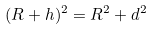<formula> <loc_0><loc_0><loc_500><loc_500>( R + h ) ^ { 2 } = R ^ { 2 } + d ^ { 2 } \,</formula> 